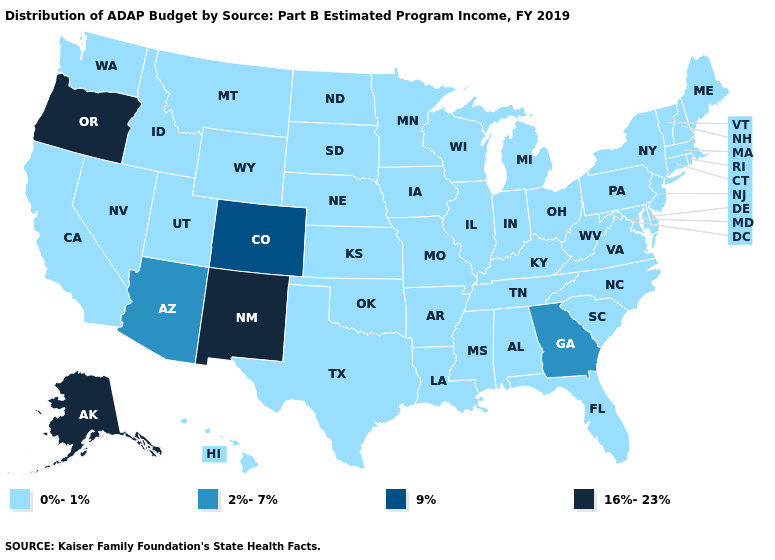Among the states that border Utah , which have the highest value?
Short answer required. New Mexico. Name the states that have a value in the range 0%-1%?
Write a very short answer. Alabama, Arkansas, California, Connecticut, Delaware, Florida, Hawaii, Idaho, Illinois, Indiana, Iowa, Kansas, Kentucky, Louisiana, Maine, Maryland, Massachusetts, Michigan, Minnesota, Mississippi, Missouri, Montana, Nebraska, Nevada, New Hampshire, New Jersey, New York, North Carolina, North Dakota, Ohio, Oklahoma, Pennsylvania, Rhode Island, South Carolina, South Dakota, Tennessee, Texas, Utah, Vermont, Virginia, Washington, West Virginia, Wisconsin, Wyoming. Name the states that have a value in the range 9%?
Be succinct. Colorado. How many symbols are there in the legend?
Keep it brief. 4. Among the states that border Colorado , which have the highest value?
Concise answer only. New Mexico. Name the states that have a value in the range 16%-23%?
Quick response, please. Alaska, New Mexico, Oregon. What is the value of Connecticut?
Be succinct. 0%-1%. What is the lowest value in the MidWest?
Concise answer only. 0%-1%. Name the states that have a value in the range 0%-1%?
Give a very brief answer. Alabama, Arkansas, California, Connecticut, Delaware, Florida, Hawaii, Idaho, Illinois, Indiana, Iowa, Kansas, Kentucky, Louisiana, Maine, Maryland, Massachusetts, Michigan, Minnesota, Mississippi, Missouri, Montana, Nebraska, Nevada, New Hampshire, New Jersey, New York, North Carolina, North Dakota, Ohio, Oklahoma, Pennsylvania, Rhode Island, South Carolina, South Dakota, Tennessee, Texas, Utah, Vermont, Virginia, Washington, West Virginia, Wisconsin, Wyoming. What is the value of Alabama?
Short answer required. 0%-1%. Does Georgia have the highest value in the South?
Quick response, please. Yes. Name the states that have a value in the range 2%-7%?
Write a very short answer. Arizona, Georgia. Does the first symbol in the legend represent the smallest category?
Answer briefly. Yes. Among the states that border West Virginia , which have the lowest value?
Write a very short answer. Kentucky, Maryland, Ohio, Pennsylvania, Virginia. What is the value of North Carolina?
Write a very short answer. 0%-1%. 